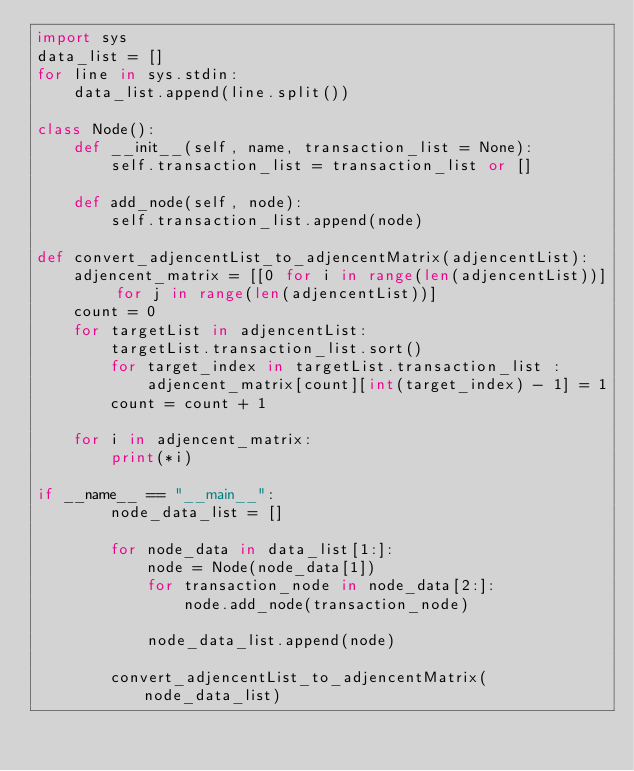Convert code to text. <code><loc_0><loc_0><loc_500><loc_500><_Python_>import sys
data_list = []
for line in sys.stdin:
	data_list.append(line.split())

class Node():
    def __init__(self, name, transaction_list = None):
        self.transaction_list = transaction_list or []

    def add_node(self, node):
        self.transaction_list.append(node)

def convert_adjencentList_to_adjencentMatrix(adjencentList):
    adjencent_matrix = [[0 for i in range(len(adjencentList))] for j in range(len(adjencentList))]
    count = 0
    for targetList in adjencentList:
        targetList.transaction_list.sort()
        for target_index in targetList.transaction_list :
            adjencent_matrix[count][int(target_index) - 1] = 1
        count = count + 1

    for i in adjencent_matrix:
        print(*i)

if __name__ == "__main__":
        node_data_list = []

        for node_data in data_list[1:]:
            node = Node(node_data[1])
            for transaction_node in node_data[2:]:
                node.add_node(transaction_node)

            node_data_list.append(node)

        convert_adjencentList_to_adjencentMatrix(node_data_list)

</code> 